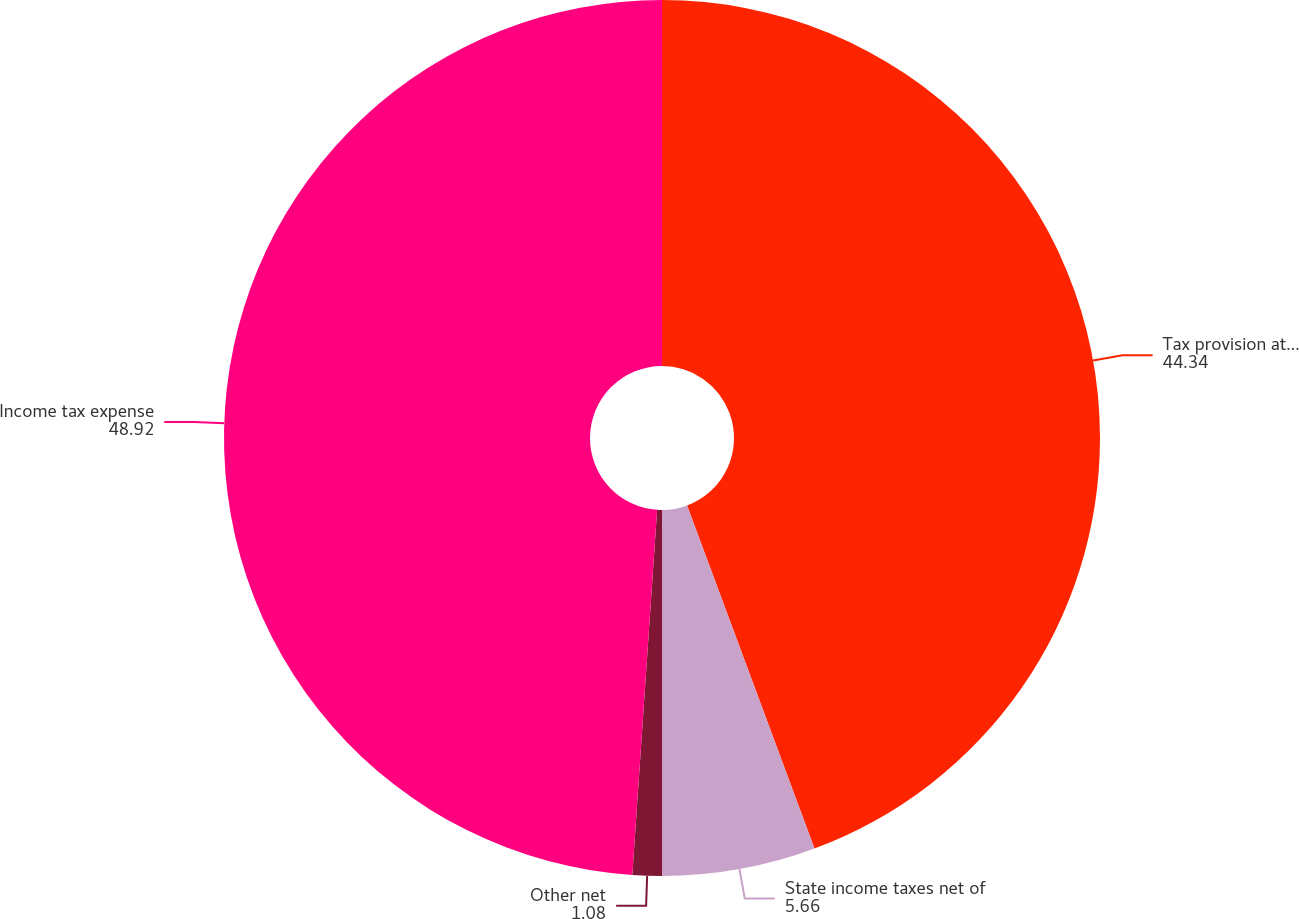Convert chart to OTSL. <chart><loc_0><loc_0><loc_500><loc_500><pie_chart><fcel>Tax provision at the US<fcel>State income taxes net of<fcel>Other net<fcel>Income tax expense<nl><fcel>44.34%<fcel>5.66%<fcel>1.08%<fcel>48.92%<nl></chart> 